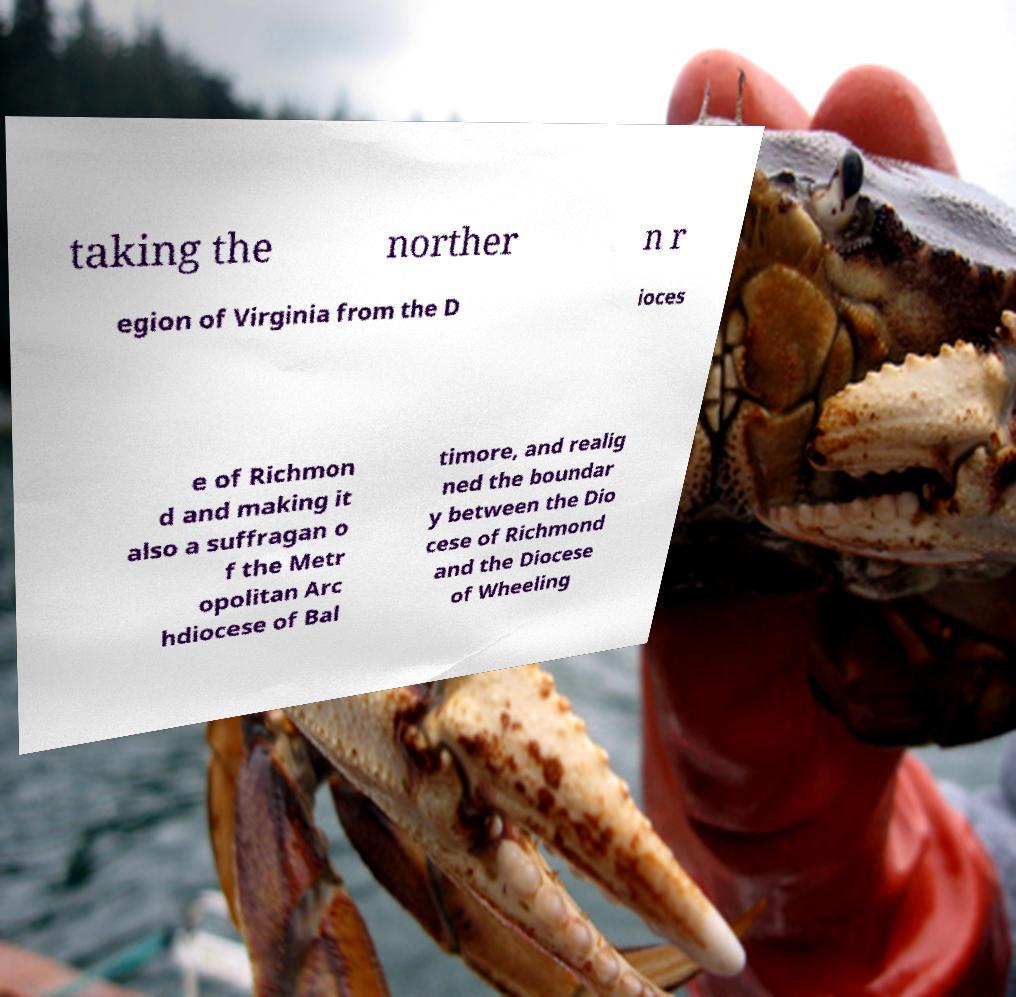Could you extract and type out the text from this image? taking the norther n r egion of Virginia from the D ioces e of Richmon d and making it also a suffragan o f the Metr opolitan Arc hdiocese of Bal timore, and realig ned the boundar y between the Dio cese of Richmond and the Diocese of Wheeling 